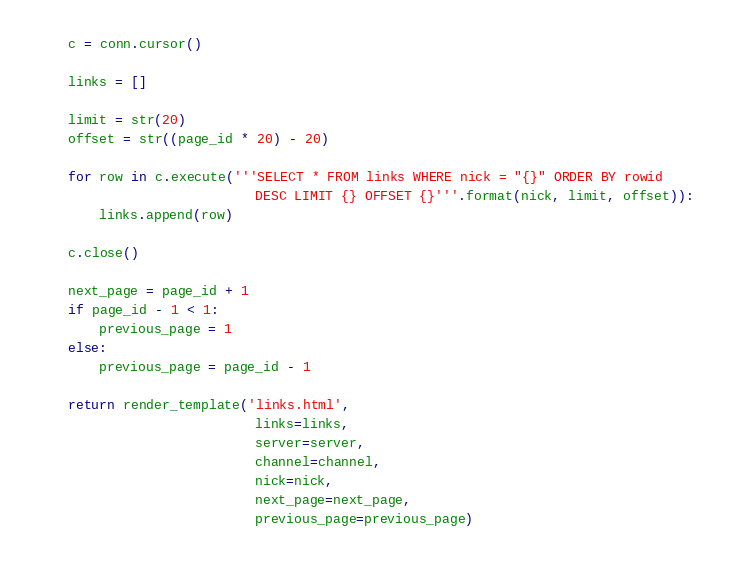Convert code to text. <code><loc_0><loc_0><loc_500><loc_500><_Python_>    c = conn.cursor()

    links = []

    limit = str(20)
    offset = str((page_id * 20) - 20)

    for row in c.execute('''SELECT * FROM links WHERE nick = "{}" ORDER BY rowid
                            DESC LIMIT {} OFFSET {}'''.format(nick, limit, offset)):
        links.append(row)

    c.close()

    next_page = page_id + 1
    if page_id - 1 < 1:
        previous_page = 1
    else:
        previous_page = page_id - 1

    return render_template('links.html',
                            links=links,
                            server=server,
                            channel=channel,
                            nick=nick,
                            next_page=next_page,
                            previous_page=previous_page)
</code> 